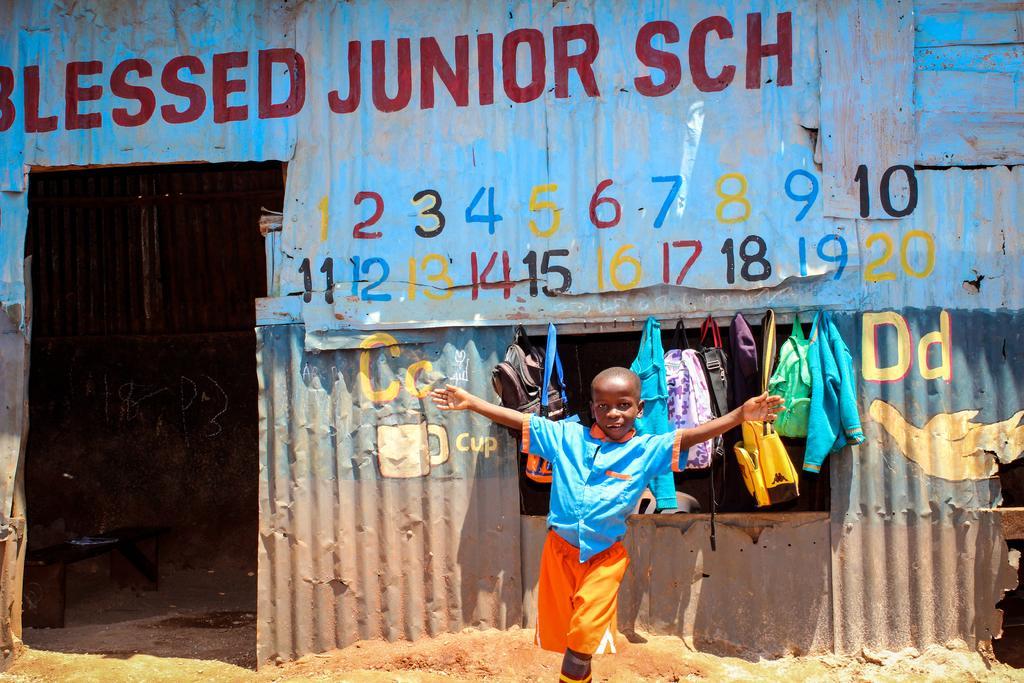Could you give a brief overview of what you see in this image? In this image we can see a boy posing for a photo and behind there are some bags and other things. We can see a shed in the background and there is some text on the shed and there is a bench on the left side of the image. 